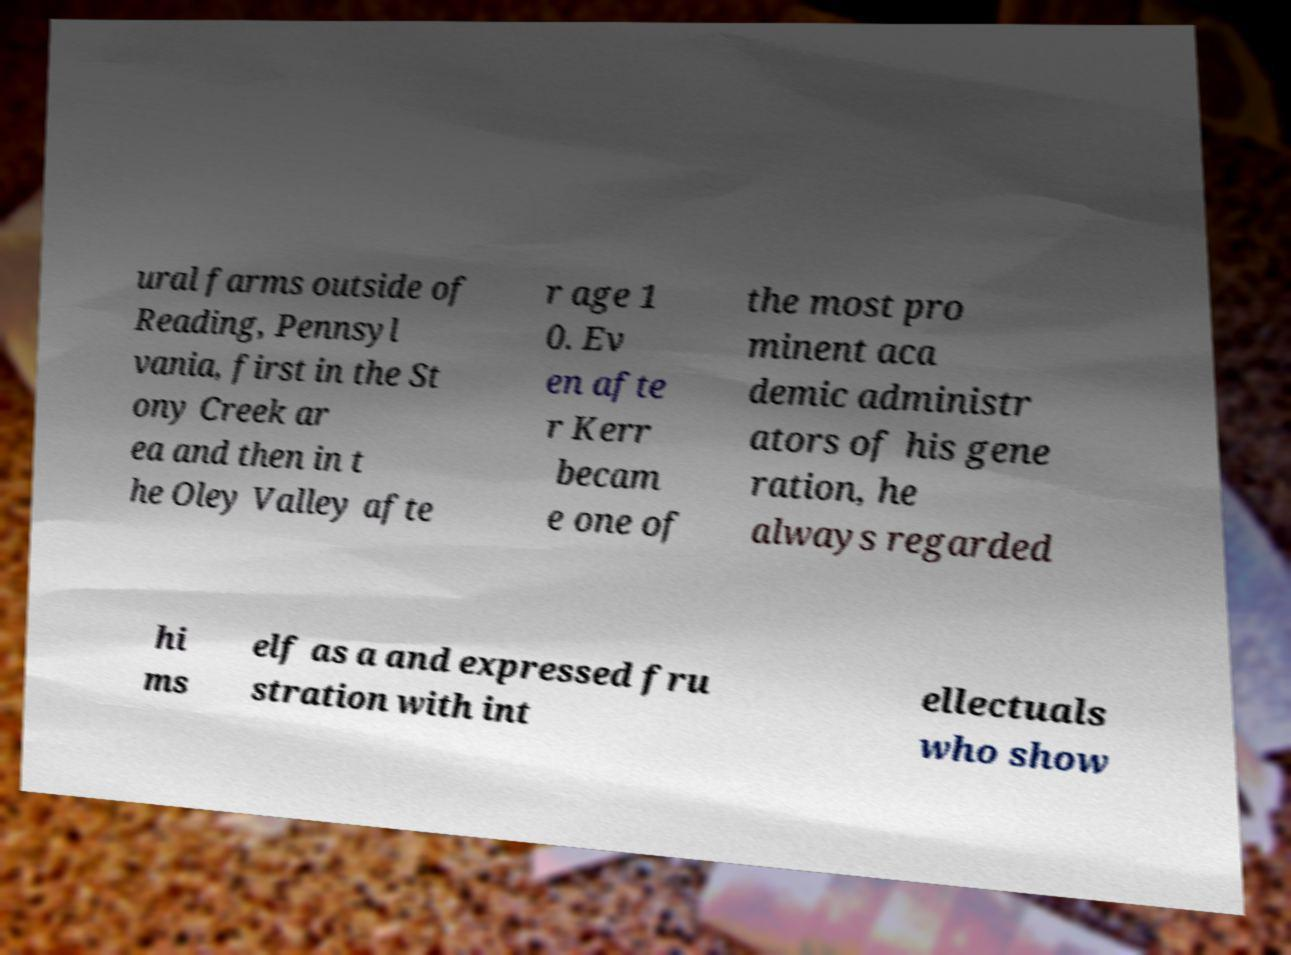Can you read and provide the text displayed in the image?This photo seems to have some interesting text. Can you extract and type it out for me? ural farms outside of Reading, Pennsyl vania, first in the St ony Creek ar ea and then in t he Oley Valley afte r age 1 0. Ev en afte r Kerr becam e one of the most pro minent aca demic administr ators of his gene ration, he always regarded hi ms elf as a and expressed fru stration with int ellectuals who show 